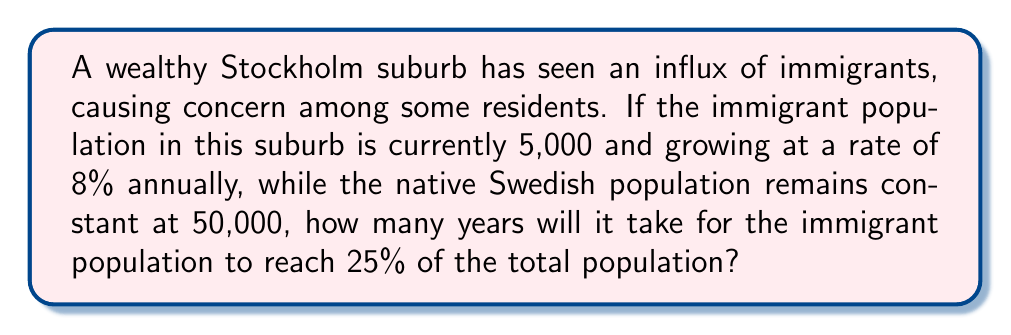Can you solve this math problem? Let's approach this step-by-step:

1) First, we need to set up an equation for the immigrant population after $t$ years:
   $P(t) = 5000 \cdot (1.08)^t$

2) We want to find when this population reaches 25% of the total population. The total population will be the sum of the immigrant population and the constant native population:
   $5000 \cdot (1.08)^t + 50000$

3) We can set up the equation:
   $\frac{5000 \cdot (1.08)^t}{5000 \cdot (1.08)^t + 50000} = 0.25$

4) Simplify:
   $5000 \cdot (1.08)^t = 0.25(5000 \cdot (1.08)^t + 50000)$
   $5000 \cdot (1.08)^t = 1250 \cdot (1.08)^t + 12500$
   $3750 \cdot (1.08)^t = 12500$
   $(1.08)^t = \frac{10}{3}$

5) Take the natural log of both sides:
   $t \cdot \ln(1.08) = \ln(\frac{10}{3})$

6) Solve for $t$:
   $t = \frac{\ln(\frac{10}{3})}{\ln(1.08)} \approx 12.28$

7) Since we can only have whole years, we round up to 13 years.
Answer: 13 years 